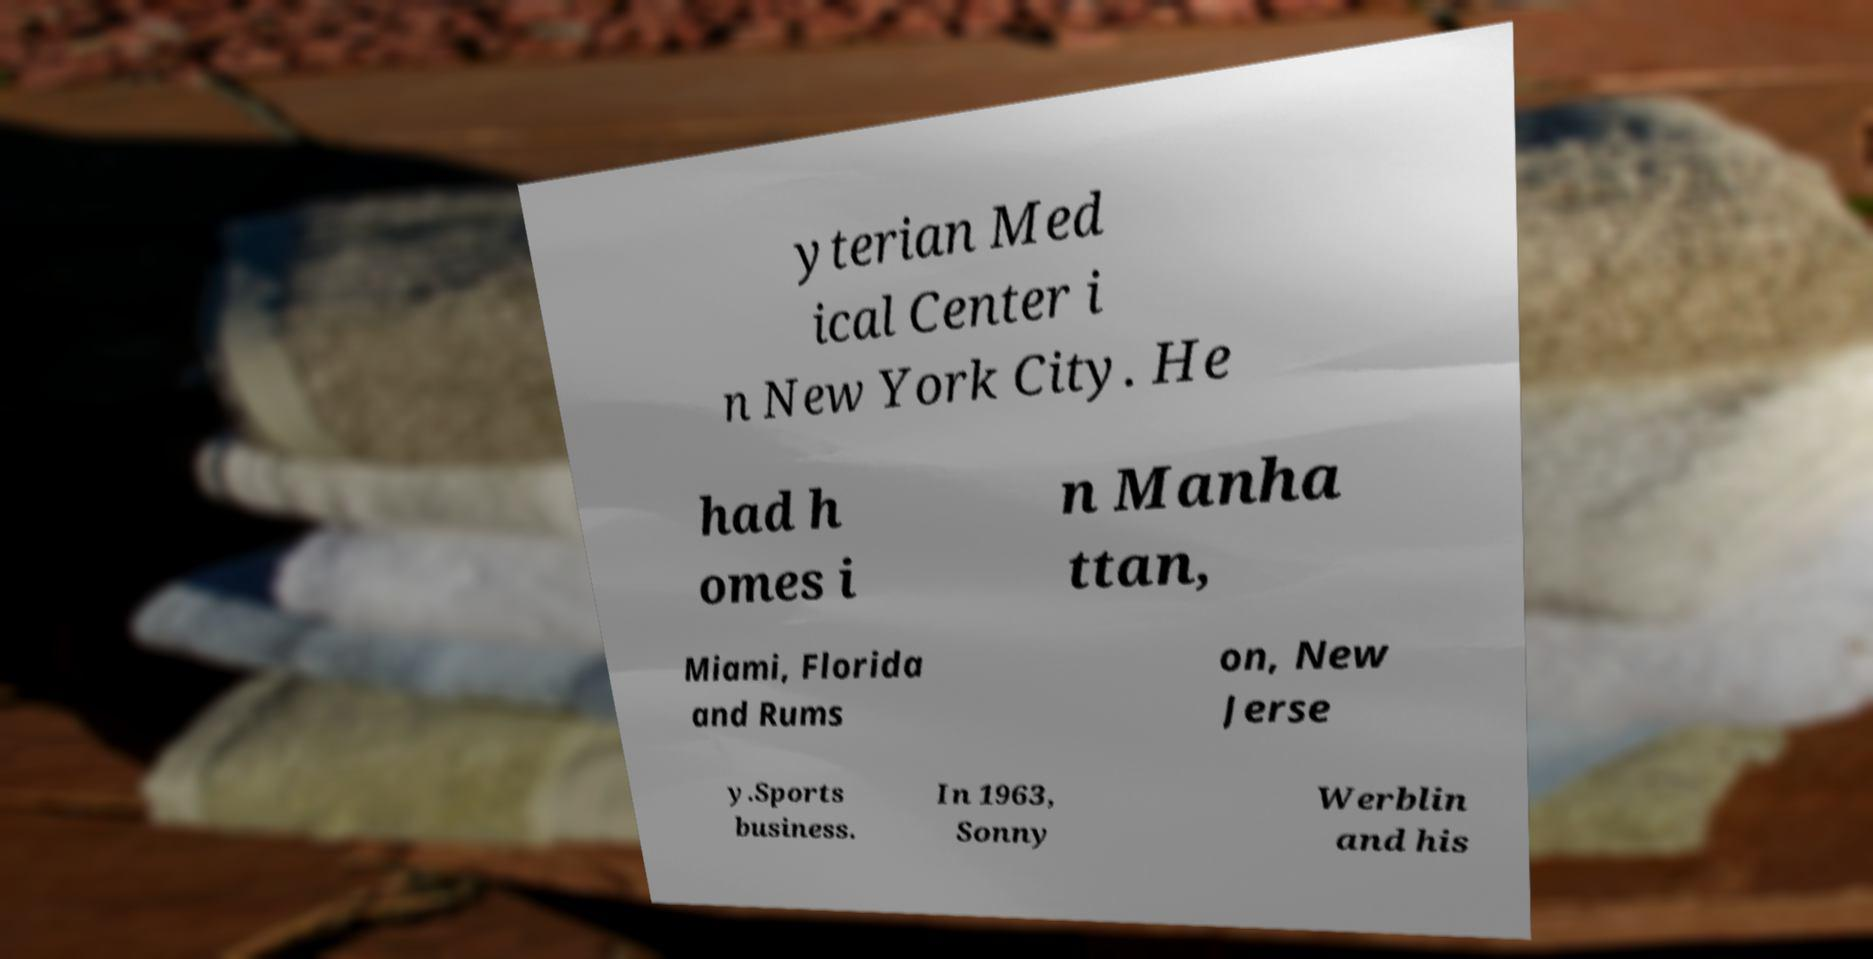Can you read and provide the text displayed in the image?This photo seems to have some interesting text. Can you extract and type it out for me? yterian Med ical Center i n New York City. He had h omes i n Manha ttan, Miami, Florida and Rums on, New Jerse y.Sports business. In 1963, Sonny Werblin and his 